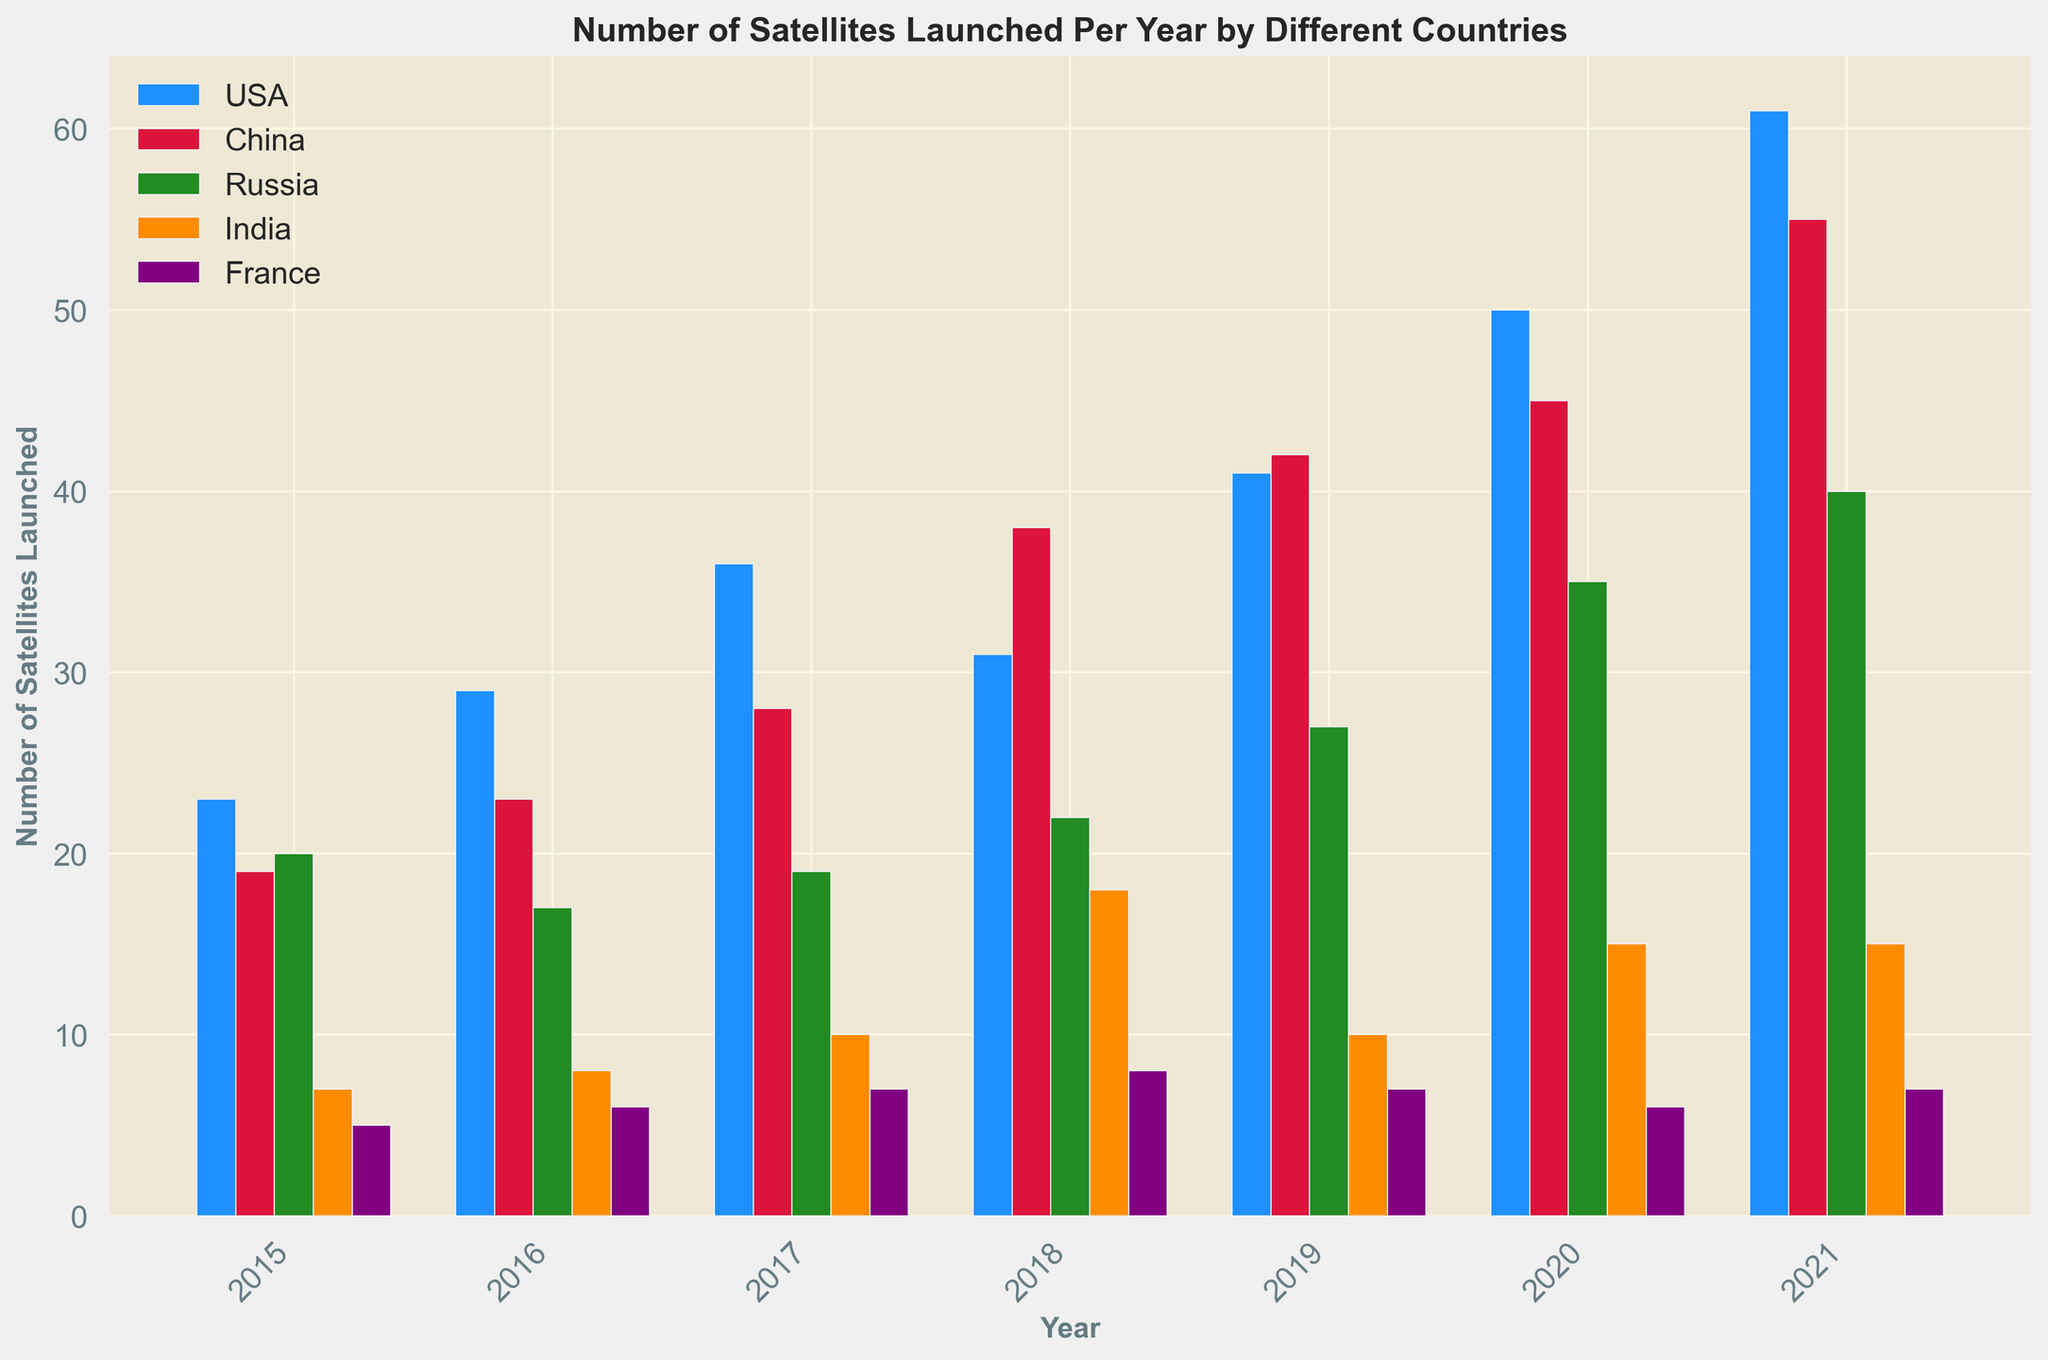Which country launched the most satellites in 2021? To find the country that launched the most satellites in 2021, look at the bar chart for the year 2021. Identify which bar is the highest and note the corresponding country.
Answer: USA Did Russia or India launch more satellites in 2018? Compare the heights of the bars for Russia and India in the year 2018. The taller bar represents the country that launched more satellites.
Answer: Russia How many more satellites did China launch in 2021 compared to 2019? First, find the number of satellites China launched in 2021 and 2019 by looking at the heights of the bars for those years. Then, subtract the number of satellites launched in 2019 from the number launched in 2021 (55 - 42).
Answer: 13 What is the average number of satellites launched by France each year from 2015 to 2021? Find the number of satellites France launched each year from 2015 to 2021 from the bar heights. Sum these numbers (5+6+7+8+7+6+7) and divide by the number of years (7).
Answer: 6.57 Which year saw the highest total number of satellites launched across all countries? Sum the number of satellites launched by each country for each year. Compare the sums to find the highest total. For example, in 2021, USA (61) + China (55) + Russia (40) + India (15) + France (7) = 178. Repeat for all years and find the maximum.
Answer: 2021 What is the overall trend for the number of satellites launched by the USA from 2015 to 2021? Look at the heights of the USA bars from 2015 to 2021. Observe whether they generally increase, decrease, or stay the same.
Answer: Increasing In which year did India see the largest single-year increase in satellite launches? Compare the launch numbers for India year to year. Identify the year with the largest difference between consecutive years, e.g., from 2017 to 2018 (18-10 = 8).
Answer: 2018 Compare the number of satellites launched by France in 2015 and 2020. How many fewer were launched in 2020? Look at the bar heights for France in 2015 and 2020 and subtract the number of satellites launched in 2020 from those launched in 2015 (5 - 6).
Answer: 1 fewer What was the difference in the number of satellites launched by China and Russia in 2017? Look at the bar heights for China and Russia in 2017. Subtract the number of satellites launched by Russia from those launched by China (28 - 19).
Answer: 9 Based on the visual data, which country shows the most consistent number of satellite launches per year? Observe the bars for each country across all years. The country with bars of similar height year-to-year shows the most consistency.
Answer: France 